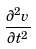Convert formula to latex. <formula><loc_0><loc_0><loc_500><loc_500>\frac { \partial ^ { 2 } v } { \partial t ^ { 2 } }</formula> 